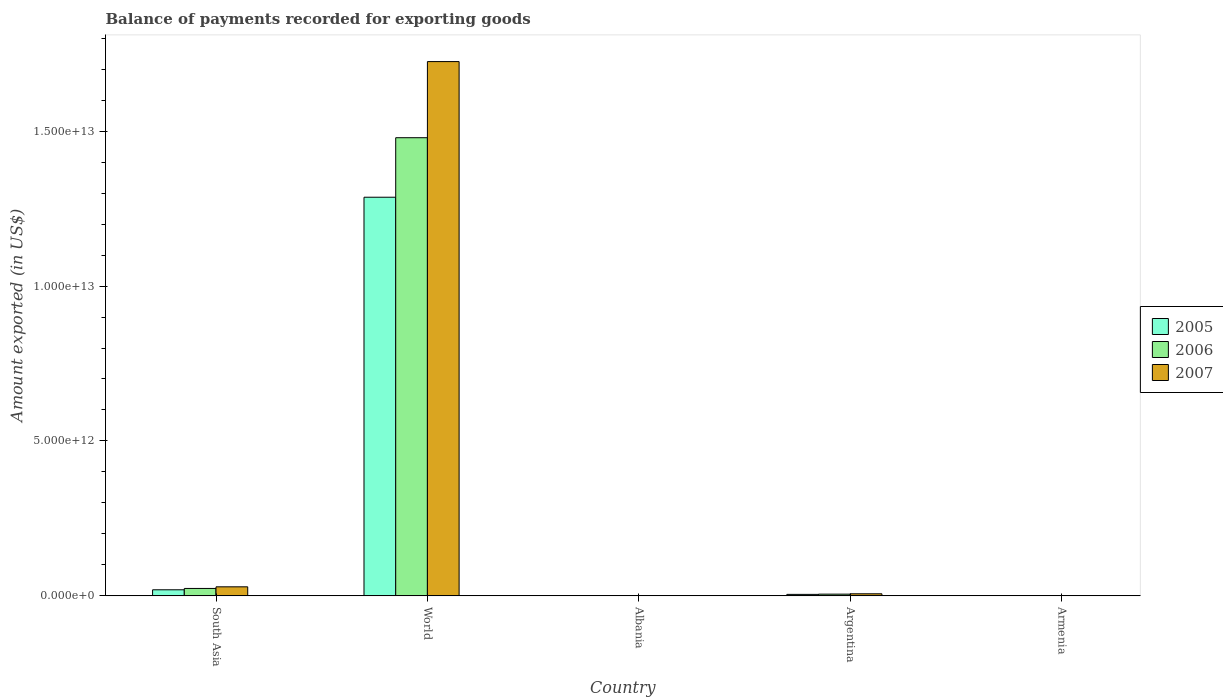Are the number of bars per tick equal to the number of legend labels?
Keep it short and to the point. Yes. Are the number of bars on each tick of the X-axis equal?
Keep it short and to the point. Yes. How many bars are there on the 1st tick from the right?
Your answer should be compact. 3. In how many cases, is the number of bars for a given country not equal to the number of legend labels?
Your answer should be compact. 0. What is the amount exported in 2007 in South Asia?
Offer a very short reply. 2.91e+11. Across all countries, what is the maximum amount exported in 2005?
Keep it short and to the point. 1.29e+13. Across all countries, what is the minimum amount exported in 2005?
Your answer should be very brief. 1.46e+09. In which country was the amount exported in 2006 minimum?
Provide a succinct answer. Armenia. What is the total amount exported in 2007 in the graph?
Provide a short and direct response. 1.76e+13. What is the difference between the amount exported in 2006 in South Asia and that in World?
Your answer should be compact. -1.46e+13. What is the difference between the amount exported in 2005 in Argentina and the amount exported in 2007 in World?
Provide a short and direct response. -1.72e+13. What is the average amount exported in 2006 per country?
Your answer should be compact. 3.02e+12. What is the difference between the amount exported of/in 2005 and amount exported of/in 2006 in Argentina?
Provide a succinct answer. -7.54e+09. What is the ratio of the amount exported in 2006 in Armenia to that in World?
Keep it short and to the point. 0. Is the amount exported in 2006 in South Asia less than that in World?
Provide a short and direct response. Yes. Is the difference between the amount exported in 2005 in Albania and World greater than the difference between the amount exported in 2006 in Albania and World?
Your response must be concise. Yes. What is the difference between the highest and the second highest amount exported in 2007?
Your answer should be very brief. -2.25e+11. What is the difference between the highest and the lowest amount exported in 2005?
Your response must be concise. 1.29e+13. Is it the case that in every country, the sum of the amount exported in 2007 and amount exported in 2006 is greater than the amount exported in 2005?
Provide a short and direct response. Yes. What is the difference between two consecutive major ticks on the Y-axis?
Offer a very short reply. 5.00e+12. Are the values on the major ticks of Y-axis written in scientific E-notation?
Your answer should be very brief. Yes. Does the graph contain any zero values?
Your response must be concise. No. Does the graph contain grids?
Provide a succinct answer. No. Where does the legend appear in the graph?
Your answer should be very brief. Center right. How many legend labels are there?
Your answer should be compact. 3. What is the title of the graph?
Provide a succinct answer. Balance of payments recorded for exporting goods. Does "1986" appear as one of the legend labels in the graph?
Your answer should be very brief. No. What is the label or title of the Y-axis?
Make the answer very short. Amount exported (in US$). What is the Amount exported (in US$) of 2005 in South Asia?
Provide a short and direct response. 1.95e+11. What is the Amount exported (in US$) in 2006 in South Asia?
Ensure brevity in your answer.  2.39e+11. What is the Amount exported (in US$) in 2007 in South Asia?
Offer a terse response. 2.91e+11. What is the Amount exported (in US$) in 2005 in World?
Your answer should be compact. 1.29e+13. What is the Amount exported (in US$) of 2006 in World?
Your response must be concise. 1.48e+13. What is the Amount exported (in US$) of 2007 in World?
Provide a succinct answer. 1.72e+13. What is the Amount exported (in US$) of 2005 in Albania?
Provide a short and direct response. 1.46e+09. What is the Amount exported (in US$) of 2006 in Albania?
Provide a short and direct response. 1.87e+09. What is the Amount exported (in US$) of 2007 in Albania?
Offer a terse response. 2.46e+09. What is the Amount exported (in US$) of 2005 in Argentina?
Give a very brief answer. 4.69e+1. What is the Amount exported (in US$) in 2006 in Argentina?
Your answer should be compact. 5.44e+1. What is the Amount exported (in US$) of 2007 in Argentina?
Provide a short and direct response. 6.62e+1. What is the Amount exported (in US$) of 2005 in Armenia?
Make the answer very short. 1.46e+09. What is the Amount exported (in US$) in 2006 in Armenia?
Your answer should be very brief. 1.65e+09. What is the Amount exported (in US$) of 2007 in Armenia?
Offer a very short reply. 1.97e+09. Across all countries, what is the maximum Amount exported (in US$) of 2005?
Ensure brevity in your answer.  1.29e+13. Across all countries, what is the maximum Amount exported (in US$) in 2006?
Offer a terse response. 1.48e+13. Across all countries, what is the maximum Amount exported (in US$) in 2007?
Provide a short and direct response. 1.72e+13. Across all countries, what is the minimum Amount exported (in US$) in 2005?
Your answer should be very brief. 1.46e+09. Across all countries, what is the minimum Amount exported (in US$) in 2006?
Provide a short and direct response. 1.65e+09. Across all countries, what is the minimum Amount exported (in US$) of 2007?
Provide a succinct answer. 1.97e+09. What is the total Amount exported (in US$) in 2005 in the graph?
Provide a short and direct response. 1.31e+13. What is the total Amount exported (in US$) of 2006 in the graph?
Provide a short and direct response. 1.51e+13. What is the total Amount exported (in US$) in 2007 in the graph?
Provide a succinct answer. 1.76e+13. What is the difference between the Amount exported (in US$) in 2005 in South Asia and that in World?
Your answer should be very brief. -1.27e+13. What is the difference between the Amount exported (in US$) in 2006 in South Asia and that in World?
Your answer should be very brief. -1.46e+13. What is the difference between the Amount exported (in US$) of 2007 in South Asia and that in World?
Provide a succinct answer. -1.70e+13. What is the difference between the Amount exported (in US$) in 2005 in South Asia and that in Albania?
Provide a succinct answer. 1.94e+11. What is the difference between the Amount exported (in US$) in 2006 in South Asia and that in Albania?
Offer a very short reply. 2.37e+11. What is the difference between the Amount exported (in US$) of 2007 in South Asia and that in Albania?
Provide a short and direct response. 2.89e+11. What is the difference between the Amount exported (in US$) of 2005 in South Asia and that in Argentina?
Provide a succinct answer. 1.49e+11. What is the difference between the Amount exported (in US$) of 2006 in South Asia and that in Argentina?
Your response must be concise. 1.84e+11. What is the difference between the Amount exported (in US$) of 2007 in South Asia and that in Argentina?
Keep it short and to the point. 2.25e+11. What is the difference between the Amount exported (in US$) of 2005 in South Asia and that in Armenia?
Ensure brevity in your answer.  1.94e+11. What is the difference between the Amount exported (in US$) of 2006 in South Asia and that in Armenia?
Keep it short and to the point. 2.37e+11. What is the difference between the Amount exported (in US$) of 2007 in South Asia and that in Armenia?
Ensure brevity in your answer.  2.89e+11. What is the difference between the Amount exported (in US$) in 2005 in World and that in Albania?
Provide a short and direct response. 1.29e+13. What is the difference between the Amount exported (in US$) in 2006 in World and that in Albania?
Offer a very short reply. 1.48e+13. What is the difference between the Amount exported (in US$) in 2007 in World and that in Albania?
Offer a very short reply. 1.72e+13. What is the difference between the Amount exported (in US$) in 2005 in World and that in Argentina?
Ensure brevity in your answer.  1.28e+13. What is the difference between the Amount exported (in US$) in 2006 in World and that in Argentina?
Keep it short and to the point. 1.47e+13. What is the difference between the Amount exported (in US$) in 2007 in World and that in Argentina?
Offer a very short reply. 1.72e+13. What is the difference between the Amount exported (in US$) of 2005 in World and that in Armenia?
Offer a terse response. 1.29e+13. What is the difference between the Amount exported (in US$) of 2006 in World and that in Armenia?
Give a very brief answer. 1.48e+13. What is the difference between the Amount exported (in US$) in 2007 in World and that in Armenia?
Your answer should be compact. 1.72e+13. What is the difference between the Amount exported (in US$) in 2005 in Albania and that in Argentina?
Ensure brevity in your answer.  -4.54e+1. What is the difference between the Amount exported (in US$) in 2006 in Albania and that in Argentina?
Offer a terse response. -5.26e+1. What is the difference between the Amount exported (in US$) in 2007 in Albania and that in Argentina?
Your answer should be very brief. -6.37e+1. What is the difference between the Amount exported (in US$) of 2005 in Albania and that in Armenia?
Your answer should be compact. 1.92e+06. What is the difference between the Amount exported (in US$) of 2006 in Albania and that in Armenia?
Provide a succinct answer. 2.23e+08. What is the difference between the Amount exported (in US$) of 2007 in Albania and that in Armenia?
Provide a short and direct response. 4.96e+08. What is the difference between the Amount exported (in US$) of 2005 in Argentina and that in Armenia?
Ensure brevity in your answer.  4.54e+1. What is the difference between the Amount exported (in US$) in 2006 in Argentina and that in Armenia?
Your response must be concise. 5.28e+1. What is the difference between the Amount exported (in US$) of 2007 in Argentina and that in Armenia?
Offer a terse response. 6.42e+1. What is the difference between the Amount exported (in US$) in 2005 in South Asia and the Amount exported (in US$) in 2006 in World?
Provide a short and direct response. -1.46e+13. What is the difference between the Amount exported (in US$) in 2005 in South Asia and the Amount exported (in US$) in 2007 in World?
Give a very brief answer. -1.71e+13. What is the difference between the Amount exported (in US$) in 2006 in South Asia and the Amount exported (in US$) in 2007 in World?
Ensure brevity in your answer.  -1.70e+13. What is the difference between the Amount exported (in US$) of 2005 in South Asia and the Amount exported (in US$) of 2006 in Albania?
Offer a very short reply. 1.94e+11. What is the difference between the Amount exported (in US$) of 2005 in South Asia and the Amount exported (in US$) of 2007 in Albania?
Your response must be concise. 1.93e+11. What is the difference between the Amount exported (in US$) in 2006 in South Asia and the Amount exported (in US$) in 2007 in Albania?
Provide a succinct answer. 2.36e+11. What is the difference between the Amount exported (in US$) of 2005 in South Asia and the Amount exported (in US$) of 2006 in Argentina?
Keep it short and to the point. 1.41e+11. What is the difference between the Amount exported (in US$) of 2005 in South Asia and the Amount exported (in US$) of 2007 in Argentina?
Your answer should be compact. 1.29e+11. What is the difference between the Amount exported (in US$) of 2006 in South Asia and the Amount exported (in US$) of 2007 in Argentina?
Offer a very short reply. 1.72e+11. What is the difference between the Amount exported (in US$) in 2005 in South Asia and the Amount exported (in US$) in 2006 in Armenia?
Make the answer very short. 1.94e+11. What is the difference between the Amount exported (in US$) of 2005 in South Asia and the Amount exported (in US$) of 2007 in Armenia?
Provide a succinct answer. 1.94e+11. What is the difference between the Amount exported (in US$) in 2006 in South Asia and the Amount exported (in US$) in 2007 in Armenia?
Give a very brief answer. 2.37e+11. What is the difference between the Amount exported (in US$) in 2005 in World and the Amount exported (in US$) in 2006 in Albania?
Your answer should be compact. 1.29e+13. What is the difference between the Amount exported (in US$) of 2005 in World and the Amount exported (in US$) of 2007 in Albania?
Your answer should be very brief. 1.29e+13. What is the difference between the Amount exported (in US$) of 2006 in World and the Amount exported (in US$) of 2007 in Albania?
Give a very brief answer. 1.48e+13. What is the difference between the Amount exported (in US$) in 2005 in World and the Amount exported (in US$) in 2006 in Argentina?
Make the answer very short. 1.28e+13. What is the difference between the Amount exported (in US$) in 2005 in World and the Amount exported (in US$) in 2007 in Argentina?
Your answer should be compact. 1.28e+13. What is the difference between the Amount exported (in US$) of 2006 in World and the Amount exported (in US$) of 2007 in Argentina?
Offer a terse response. 1.47e+13. What is the difference between the Amount exported (in US$) in 2005 in World and the Amount exported (in US$) in 2006 in Armenia?
Offer a very short reply. 1.29e+13. What is the difference between the Amount exported (in US$) of 2005 in World and the Amount exported (in US$) of 2007 in Armenia?
Ensure brevity in your answer.  1.29e+13. What is the difference between the Amount exported (in US$) in 2006 in World and the Amount exported (in US$) in 2007 in Armenia?
Make the answer very short. 1.48e+13. What is the difference between the Amount exported (in US$) in 2005 in Albania and the Amount exported (in US$) in 2006 in Argentina?
Offer a terse response. -5.30e+1. What is the difference between the Amount exported (in US$) in 2005 in Albania and the Amount exported (in US$) in 2007 in Argentina?
Offer a terse response. -6.47e+1. What is the difference between the Amount exported (in US$) in 2006 in Albania and the Amount exported (in US$) in 2007 in Argentina?
Offer a very short reply. -6.43e+1. What is the difference between the Amount exported (in US$) in 2005 in Albania and the Amount exported (in US$) in 2006 in Armenia?
Give a very brief answer. -1.86e+08. What is the difference between the Amount exported (in US$) of 2005 in Albania and the Amount exported (in US$) of 2007 in Armenia?
Provide a succinct answer. -5.08e+08. What is the difference between the Amount exported (in US$) in 2006 in Albania and the Amount exported (in US$) in 2007 in Armenia?
Make the answer very short. -9.89e+07. What is the difference between the Amount exported (in US$) in 2005 in Argentina and the Amount exported (in US$) in 2006 in Armenia?
Offer a terse response. 4.52e+1. What is the difference between the Amount exported (in US$) of 2005 in Argentina and the Amount exported (in US$) of 2007 in Armenia?
Provide a short and direct response. 4.49e+1. What is the difference between the Amount exported (in US$) of 2006 in Argentina and the Amount exported (in US$) of 2007 in Armenia?
Your response must be concise. 5.25e+1. What is the average Amount exported (in US$) of 2005 per country?
Make the answer very short. 2.62e+12. What is the average Amount exported (in US$) of 2006 per country?
Offer a very short reply. 3.02e+12. What is the average Amount exported (in US$) of 2007 per country?
Offer a very short reply. 3.52e+12. What is the difference between the Amount exported (in US$) in 2005 and Amount exported (in US$) in 2006 in South Asia?
Your answer should be very brief. -4.30e+1. What is the difference between the Amount exported (in US$) in 2005 and Amount exported (in US$) in 2007 in South Asia?
Your answer should be very brief. -9.56e+1. What is the difference between the Amount exported (in US$) of 2006 and Amount exported (in US$) of 2007 in South Asia?
Provide a succinct answer. -5.26e+1. What is the difference between the Amount exported (in US$) in 2005 and Amount exported (in US$) in 2006 in World?
Offer a very short reply. -1.92e+12. What is the difference between the Amount exported (in US$) in 2005 and Amount exported (in US$) in 2007 in World?
Your answer should be very brief. -4.38e+12. What is the difference between the Amount exported (in US$) in 2006 and Amount exported (in US$) in 2007 in World?
Your answer should be very brief. -2.46e+12. What is the difference between the Amount exported (in US$) of 2005 and Amount exported (in US$) of 2006 in Albania?
Offer a terse response. -4.09e+08. What is the difference between the Amount exported (in US$) of 2005 and Amount exported (in US$) of 2007 in Albania?
Keep it short and to the point. -1.00e+09. What is the difference between the Amount exported (in US$) of 2006 and Amount exported (in US$) of 2007 in Albania?
Ensure brevity in your answer.  -5.95e+08. What is the difference between the Amount exported (in US$) of 2005 and Amount exported (in US$) of 2006 in Argentina?
Provide a short and direct response. -7.54e+09. What is the difference between the Amount exported (in US$) in 2005 and Amount exported (in US$) in 2007 in Argentina?
Your response must be concise. -1.93e+1. What is the difference between the Amount exported (in US$) of 2006 and Amount exported (in US$) of 2007 in Argentina?
Offer a terse response. -1.17e+1. What is the difference between the Amount exported (in US$) of 2005 and Amount exported (in US$) of 2006 in Armenia?
Your answer should be compact. -1.88e+08. What is the difference between the Amount exported (in US$) of 2005 and Amount exported (in US$) of 2007 in Armenia?
Offer a very short reply. -5.10e+08. What is the difference between the Amount exported (in US$) of 2006 and Amount exported (in US$) of 2007 in Armenia?
Provide a succinct answer. -3.22e+08. What is the ratio of the Amount exported (in US$) of 2005 in South Asia to that in World?
Offer a very short reply. 0.02. What is the ratio of the Amount exported (in US$) in 2006 in South Asia to that in World?
Make the answer very short. 0.02. What is the ratio of the Amount exported (in US$) of 2007 in South Asia to that in World?
Offer a terse response. 0.02. What is the ratio of the Amount exported (in US$) in 2005 in South Asia to that in Albania?
Your answer should be very brief. 133.81. What is the ratio of the Amount exported (in US$) of 2006 in South Asia to that in Albania?
Provide a succinct answer. 127.58. What is the ratio of the Amount exported (in US$) in 2007 in South Asia to that in Albania?
Provide a short and direct response. 118.12. What is the ratio of the Amount exported (in US$) in 2005 in South Asia to that in Argentina?
Offer a very short reply. 4.17. What is the ratio of the Amount exported (in US$) of 2006 in South Asia to that in Argentina?
Your response must be concise. 4.38. What is the ratio of the Amount exported (in US$) in 2007 in South Asia to that in Argentina?
Your answer should be compact. 4.4. What is the ratio of the Amount exported (in US$) in 2005 in South Asia to that in Armenia?
Give a very brief answer. 133.99. What is the ratio of the Amount exported (in US$) of 2006 in South Asia to that in Armenia?
Provide a short and direct response. 144.85. What is the ratio of the Amount exported (in US$) in 2007 in South Asia to that in Armenia?
Provide a short and direct response. 147.88. What is the ratio of the Amount exported (in US$) of 2005 in World to that in Albania?
Provide a succinct answer. 8808.63. What is the ratio of the Amount exported (in US$) in 2006 in World to that in Albania?
Ensure brevity in your answer.  7910.28. What is the ratio of the Amount exported (in US$) in 2007 in World to that in Albania?
Provide a succinct answer. 6998.11. What is the ratio of the Amount exported (in US$) in 2005 in World to that in Argentina?
Provide a short and direct response. 274.4. What is the ratio of the Amount exported (in US$) in 2006 in World to that in Argentina?
Offer a very short reply. 271.7. What is the ratio of the Amount exported (in US$) in 2007 in World to that in Argentina?
Offer a very short reply. 260.64. What is the ratio of the Amount exported (in US$) in 2005 in World to that in Armenia?
Make the answer very short. 8820.25. What is the ratio of the Amount exported (in US$) in 2006 in World to that in Armenia?
Offer a terse response. 8980.84. What is the ratio of the Amount exported (in US$) of 2007 in World to that in Armenia?
Make the answer very short. 8761.26. What is the ratio of the Amount exported (in US$) in 2005 in Albania to that in Argentina?
Make the answer very short. 0.03. What is the ratio of the Amount exported (in US$) of 2006 in Albania to that in Argentina?
Provide a succinct answer. 0.03. What is the ratio of the Amount exported (in US$) of 2007 in Albania to that in Argentina?
Offer a very short reply. 0.04. What is the ratio of the Amount exported (in US$) of 2005 in Albania to that in Armenia?
Your answer should be very brief. 1. What is the ratio of the Amount exported (in US$) in 2006 in Albania to that in Armenia?
Provide a succinct answer. 1.14. What is the ratio of the Amount exported (in US$) of 2007 in Albania to that in Armenia?
Your response must be concise. 1.25. What is the ratio of the Amount exported (in US$) of 2005 in Argentina to that in Armenia?
Offer a terse response. 32.14. What is the ratio of the Amount exported (in US$) in 2006 in Argentina to that in Armenia?
Provide a succinct answer. 33.05. What is the ratio of the Amount exported (in US$) in 2007 in Argentina to that in Armenia?
Your answer should be compact. 33.61. What is the difference between the highest and the second highest Amount exported (in US$) of 2005?
Your response must be concise. 1.27e+13. What is the difference between the highest and the second highest Amount exported (in US$) of 2006?
Give a very brief answer. 1.46e+13. What is the difference between the highest and the second highest Amount exported (in US$) of 2007?
Offer a terse response. 1.70e+13. What is the difference between the highest and the lowest Amount exported (in US$) of 2005?
Provide a succinct answer. 1.29e+13. What is the difference between the highest and the lowest Amount exported (in US$) in 2006?
Provide a short and direct response. 1.48e+13. What is the difference between the highest and the lowest Amount exported (in US$) in 2007?
Your answer should be compact. 1.72e+13. 